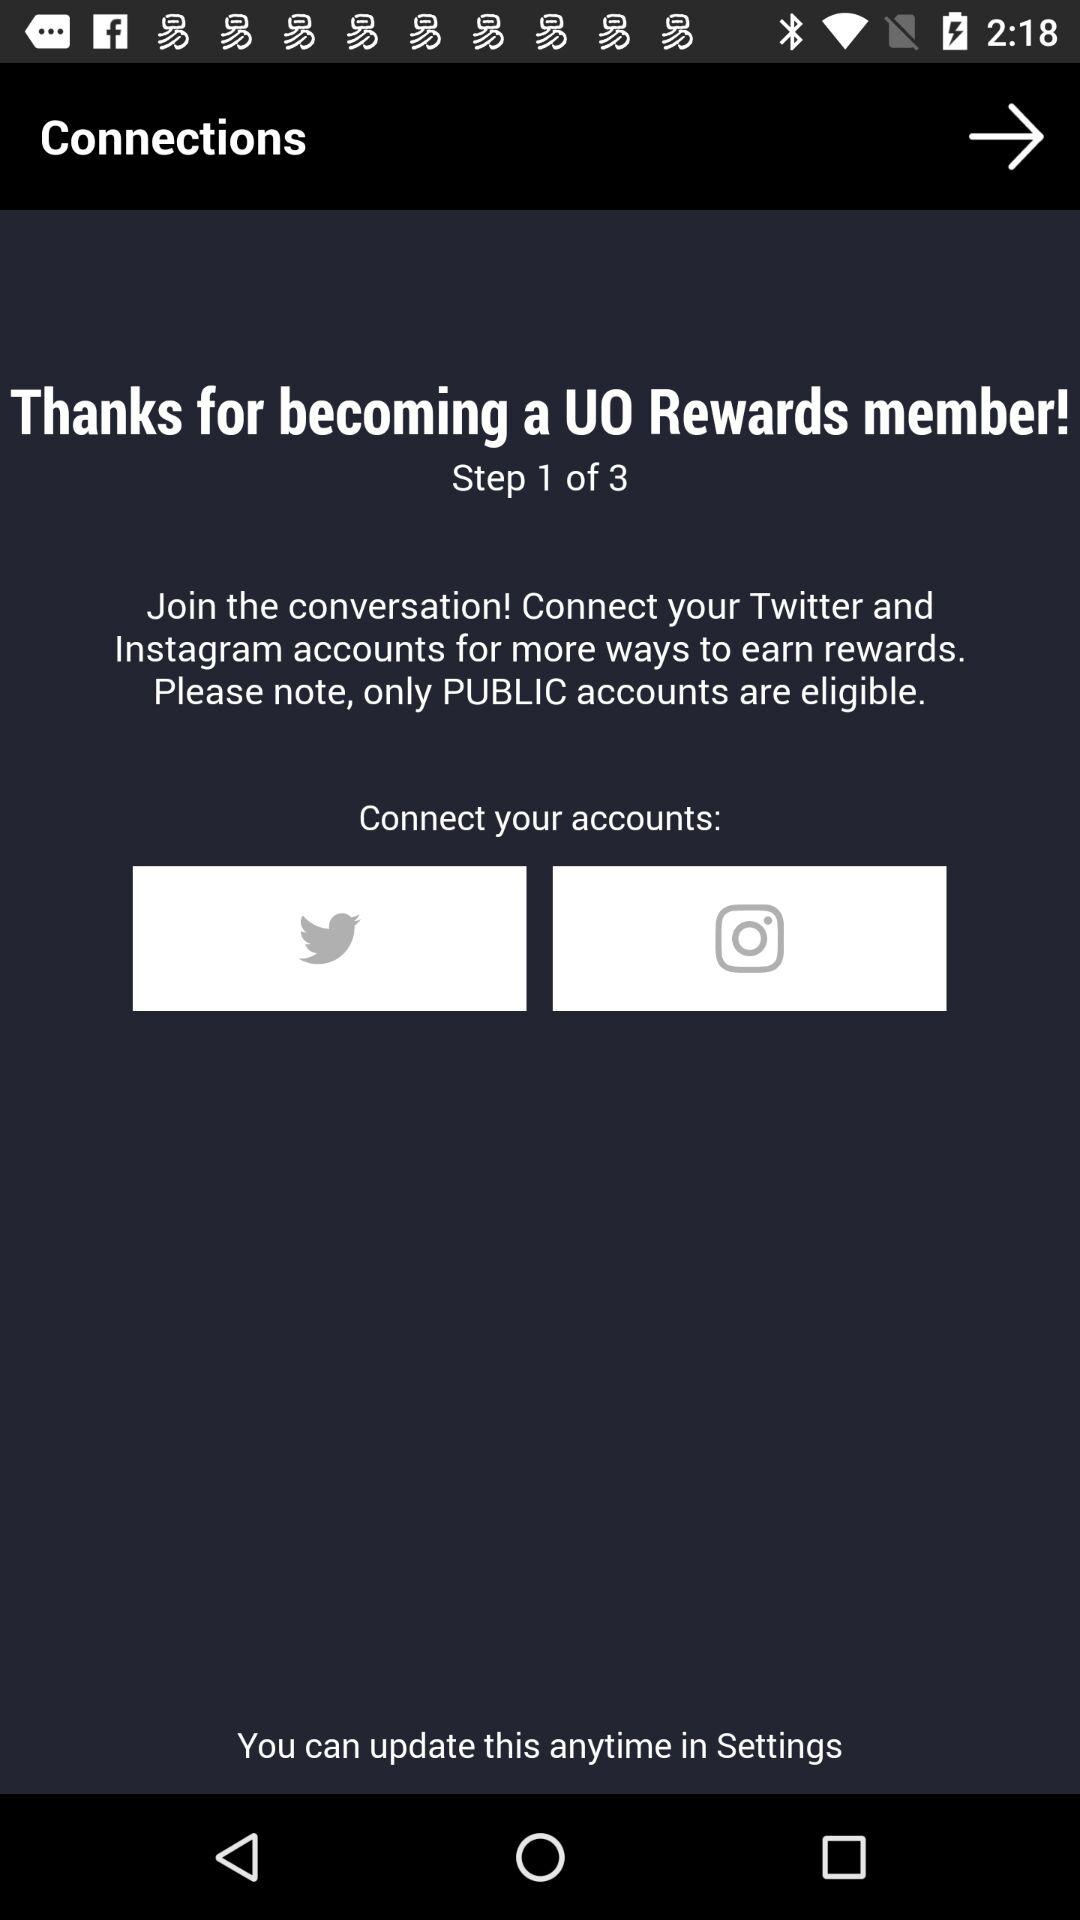What's the current step number? The current step number is 1. 